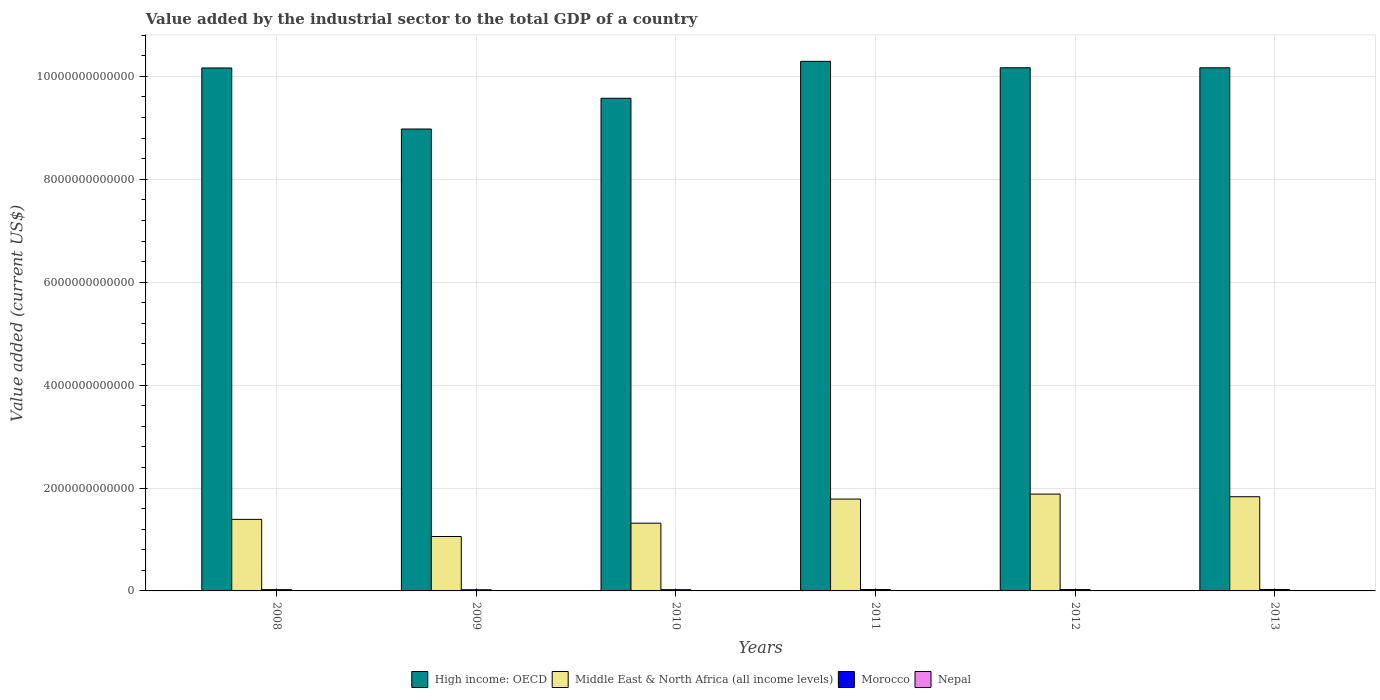How many different coloured bars are there?
Give a very brief answer. 4. How many groups of bars are there?
Make the answer very short. 6. Are the number of bars per tick equal to the number of legend labels?
Provide a succinct answer. Yes. In how many cases, is the number of bars for a given year not equal to the number of legend labels?
Ensure brevity in your answer.  0. What is the value added by the industrial sector to the total GDP in High income: OECD in 2008?
Your response must be concise. 1.02e+13. Across all years, what is the maximum value added by the industrial sector to the total GDP in Nepal?
Your answer should be compact. 2.73e+09. Across all years, what is the minimum value added by the industrial sector to the total GDP in Nepal?
Provide a succinct answer. 1.94e+09. In which year was the value added by the industrial sector to the total GDP in Nepal maximum?
Your answer should be very brief. 2013. What is the total value added by the industrial sector to the total GDP in Morocco in the graph?
Make the answer very short. 1.52e+11. What is the difference between the value added by the industrial sector to the total GDP in Morocco in 2009 and that in 2011?
Ensure brevity in your answer.  -4.46e+09. What is the difference between the value added by the industrial sector to the total GDP in Middle East & North Africa (all income levels) in 2010 and the value added by the industrial sector to the total GDP in Morocco in 2009?
Ensure brevity in your answer.  1.29e+12. What is the average value added by the industrial sector to the total GDP in Middle East & North Africa (all income levels) per year?
Provide a succinct answer. 1.54e+12. In the year 2012, what is the difference between the value added by the industrial sector to the total GDP in Morocco and value added by the industrial sector to the total GDP in Middle East & North Africa (all income levels)?
Ensure brevity in your answer.  -1.86e+12. In how many years, is the value added by the industrial sector to the total GDP in Middle East & North Africa (all income levels) greater than 4000000000000 US$?
Your response must be concise. 0. What is the ratio of the value added by the industrial sector to the total GDP in Nepal in 2010 to that in 2012?
Give a very brief answer. 0.85. What is the difference between the highest and the second highest value added by the industrial sector to the total GDP in Middle East & North Africa (all income levels)?
Offer a very short reply. 5.11e+1. What is the difference between the highest and the lowest value added by the industrial sector to the total GDP in Morocco?
Keep it short and to the point. 5.56e+09. In how many years, is the value added by the industrial sector to the total GDP in Middle East & North Africa (all income levels) greater than the average value added by the industrial sector to the total GDP in Middle East & North Africa (all income levels) taken over all years?
Offer a terse response. 3. Is the sum of the value added by the industrial sector to the total GDP in High income: OECD in 2008 and 2011 greater than the maximum value added by the industrial sector to the total GDP in Nepal across all years?
Offer a terse response. Yes. Is it the case that in every year, the sum of the value added by the industrial sector to the total GDP in High income: OECD and value added by the industrial sector to the total GDP in Morocco is greater than the sum of value added by the industrial sector to the total GDP in Middle East & North Africa (all income levels) and value added by the industrial sector to the total GDP in Nepal?
Offer a very short reply. Yes. What does the 3rd bar from the left in 2011 represents?
Offer a very short reply. Morocco. What does the 2nd bar from the right in 2011 represents?
Provide a short and direct response. Morocco. Are all the bars in the graph horizontal?
Ensure brevity in your answer.  No. How many years are there in the graph?
Your answer should be compact. 6. What is the difference between two consecutive major ticks on the Y-axis?
Provide a succinct answer. 2.00e+12. Are the values on the major ticks of Y-axis written in scientific E-notation?
Provide a short and direct response. No. Does the graph contain any zero values?
Your response must be concise. No. Where does the legend appear in the graph?
Give a very brief answer. Bottom center. How are the legend labels stacked?
Your response must be concise. Horizontal. What is the title of the graph?
Your response must be concise. Value added by the industrial sector to the total GDP of a country. What is the label or title of the Y-axis?
Ensure brevity in your answer.  Value added (current US$). What is the Value added (current US$) of High income: OECD in 2008?
Your answer should be very brief. 1.02e+13. What is the Value added (current US$) in Middle East & North Africa (all income levels) in 2008?
Provide a short and direct response. 1.39e+12. What is the Value added (current US$) in Morocco in 2008?
Provide a short and direct response. 2.48e+1. What is the Value added (current US$) of Nepal in 2008?
Provide a succinct answer. 2.01e+09. What is the Value added (current US$) of High income: OECD in 2009?
Offer a very short reply. 8.98e+12. What is the Value added (current US$) in Middle East & North Africa (all income levels) in 2009?
Make the answer very short. 1.06e+12. What is the Value added (current US$) of Morocco in 2009?
Offer a terse response. 2.25e+1. What is the Value added (current US$) in Nepal in 2009?
Make the answer very short. 1.94e+09. What is the Value added (current US$) of High income: OECD in 2010?
Keep it short and to the point. 9.57e+12. What is the Value added (current US$) of Middle East & North Africa (all income levels) in 2010?
Offer a terse response. 1.32e+12. What is the Value added (current US$) in Morocco in 2010?
Offer a very short reply. 2.39e+1. What is the Value added (current US$) of Nepal in 2010?
Keep it short and to the point. 2.27e+09. What is the Value added (current US$) in High income: OECD in 2011?
Provide a short and direct response. 1.03e+13. What is the Value added (current US$) of Middle East & North Africa (all income levels) in 2011?
Your answer should be compact. 1.79e+12. What is the Value added (current US$) in Morocco in 2011?
Provide a succinct answer. 2.70e+1. What is the Value added (current US$) of Nepal in 2011?
Give a very brief answer. 2.67e+09. What is the Value added (current US$) of High income: OECD in 2012?
Your answer should be compact. 1.02e+13. What is the Value added (current US$) of Middle East & North Africa (all income levels) in 2012?
Make the answer very short. 1.88e+12. What is the Value added (current US$) in Morocco in 2012?
Provide a succinct answer. 2.59e+1. What is the Value added (current US$) of Nepal in 2012?
Your response must be concise. 2.66e+09. What is the Value added (current US$) in High income: OECD in 2013?
Ensure brevity in your answer.  1.02e+13. What is the Value added (current US$) in Middle East & North Africa (all income levels) in 2013?
Offer a very short reply. 1.83e+12. What is the Value added (current US$) of Morocco in 2013?
Provide a succinct answer. 2.81e+1. What is the Value added (current US$) of Nepal in 2013?
Make the answer very short. 2.73e+09. Across all years, what is the maximum Value added (current US$) in High income: OECD?
Your answer should be very brief. 1.03e+13. Across all years, what is the maximum Value added (current US$) in Middle East & North Africa (all income levels)?
Your response must be concise. 1.88e+12. Across all years, what is the maximum Value added (current US$) in Morocco?
Provide a succinct answer. 2.81e+1. Across all years, what is the maximum Value added (current US$) in Nepal?
Your answer should be compact. 2.73e+09. Across all years, what is the minimum Value added (current US$) in High income: OECD?
Provide a succinct answer. 8.98e+12. Across all years, what is the minimum Value added (current US$) of Middle East & North Africa (all income levels)?
Your answer should be compact. 1.06e+12. Across all years, what is the minimum Value added (current US$) of Morocco?
Offer a terse response. 2.25e+1. Across all years, what is the minimum Value added (current US$) of Nepal?
Keep it short and to the point. 1.94e+09. What is the total Value added (current US$) in High income: OECD in the graph?
Give a very brief answer. 5.93e+13. What is the total Value added (current US$) of Middle East & North Africa (all income levels) in the graph?
Offer a terse response. 9.26e+12. What is the total Value added (current US$) of Morocco in the graph?
Give a very brief answer. 1.52e+11. What is the total Value added (current US$) of Nepal in the graph?
Your response must be concise. 1.43e+1. What is the difference between the Value added (current US$) of High income: OECD in 2008 and that in 2009?
Provide a succinct answer. 1.19e+12. What is the difference between the Value added (current US$) in Middle East & North Africa (all income levels) in 2008 and that in 2009?
Give a very brief answer. 3.33e+11. What is the difference between the Value added (current US$) in Morocco in 2008 and that in 2009?
Ensure brevity in your answer.  2.24e+09. What is the difference between the Value added (current US$) in Nepal in 2008 and that in 2009?
Keep it short and to the point. 7.67e+07. What is the difference between the Value added (current US$) of High income: OECD in 2008 and that in 2010?
Give a very brief answer. 5.89e+11. What is the difference between the Value added (current US$) of Middle East & North Africa (all income levels) in 2008 and that in 2010?
Ensure brevity in your answer.  7.39e+1. What is the difference between the Value added (current US$) in Morocco in 2008 and that in 2010?
Give a very brief answer. 8.42e+08. What is the difference between the Value added (current US$) of Nepal in 2008 and that in 2010?
Provide a succinct answer. -2.59e+08. What is the difference between the Value added (current US$) in High income: OECD in 2008 and that in 2011?
Ensure brevity in your answer.  -1.28e+11. What is the difference between the Value added (current US$) of Middle East & North Africa (all income levels) in 2008 and that in 2011?
Provide a succinct answer. -3.95e+11. What is the difference between the Value added (current US$) in Morocco in 2008 and that in 2011?
Offer a terse response. -2.22e+09. What is the difference between the Value added (current US$) of Nepal in 2008 and that in 2011?
Ensure brevity in your answer.  -6.55e+08. What is the difference between the Value added (current US$) in High income: OECD in 2008 and that in 2012?
Your response must be concise. -4.01e+09. What is the difference between the Value added (current US$) of Middle East & North Africa (all income levels) in 2008 and that in 2012?
Give a very brief answer. -4.91e+11. What is the difference between the Value added (current US$) of Morocco in 2008 and that in 2012?
Your answer should be very brief. -1.19e+09. What is the difference between the Value added (current US$) of Nepal in 2008 and that in 2012?
Offer a terse response. -6.45e+08. What is the difference between the Value added (current US$) in High income: OECD in 2008 and that in 2013?
Ensure brevity in your answer.  -3.16e+09. What is the difference between the Value added (current US$) in Middle East & North Africa (all income levels) in 2008 and that in 2013?
Offer a terse response. -4.40e+11. What is the difference between the Value added (current US$) of Morocco in 2008 and that in 2013?
Ensure brevity in your answer.  -3.32e+09. What is the difference between the Value added (current US$) in Nepal in 2008 and that in 2013?
Your response must be concise. -7.14e+08. What is the difference between the Value added (current US$) in High income: OECD in 2009 and that in 2010?
Make the answer very short. -5.98e+11. What is the difference between the Value added (current US$) of Middle East & North Africa (all income levels) in 2009 and that in 2010?
Offer a very short reply. -2.59e+11. What is the difference between the Value added (current US$) of Morocco in 2009 and that in 2010?
Ensure brevity in your answer.  -1.40e+09. What is the difference between the Value added (current US$) in Nepal in 2009 and that in 2010?
Ensure brevity in your answer.  -3.36e+08. What is the difference between the Value added (current US$) in High income: OECD in 2009 and that in 2011?
Give a very brief answer. -1.32e+12. What is the difference between the Value added (current US$) of Middle East & North Africa (all income levels) in 2009 and that in 2011?
Keep it short and to the point. -7.28e+11. What is the difference between the Value added (current US$) in Morocco in 2009 and that in 2011?
Provide a succinct answer. -4.46e+09. What is the difference between the Value added (current US$) of Nepal in 2009 and that in 2011?
Your response must be concise. -7.31e+08. What is the difference between the Value added (current US$) in High income: OECD in 2009 and that in 2012?
Offer a very short reply. -1.19e+12. What is the difference between the Value added (current US$) in Middle East & North Africa (all income levels) in 2009 and that in 2012?
Offer a terse response. -8.24e+11. What is the difference between the Value added (current US$) of Morocco in 2009 and that in 2012?
Offer a terse response. -3.43e+09. What is the difference between the Value added (current US$) of Nepal in 2009 and that in 2012?
Offer a very short reply. -7.22e+08. What is the difference between the Value added (current US$) of High income: OECD in 2009 and that in 2013?
Give a very brief answer. -1.19e+12. What is the difference between the Value added (current US$) in Middle East & North Africa (all income levels) in 2009 and that in 2013?
Your answer should be compact. -7.73e+11. What is the difference between the Value added (current US$) of Morocco in 2009 and that in 2013?
Offer a terse response. -5.56e+09. What is the difference between the Value added (current US$) of Nepal in 2009 and that in 2013?
Offer a very short reply. -7.91e+08. What is the difference between the Value added (current US$) of High income: OECD in 2010 and that in 2011?
Provide a succinct answer. -7.17e+11. What is the difference between the Value added (current US$) of Middle East & North Africa (all income levels) in 2010 and that in 2011?
Provide a short and direct response. -4.69e+11. What is the difference between the Value added (current US$) of Morocco in 2010 and that in 2011?
Your answer should be very brief. -3.06e+09. What is the difference between the Value added (current US$) of Nepal in 2010 and that in 2011?
Your answer should be compact. -3.96e+08. What is the difference between the Value added (current US$) of High income: OECD in 2010 and that in 2012?
Provide a succinct answer. -5.93e+11. What is the difference between the Value added (current US$) in Middle East & North Africa (all income levels) in 2010 and that in 2012?
Give a very brief answer. -5.65e+11. What is the difference between the Value added (current US$) in Morocco in 2010 and that in 2012?
Your answer should be compact. -2.03e+09. What is the difference between the Value added (current US$) in Nepal in 2010 and that in 2012?
Give a very brief answer. -3.86e+08. What is the difference between the Value added (current US$) in High income: OECD in 2010 and that in 2013?
Your response must be concise. -5.92e+11. What is the difference between the Value added (current US$) in Middle East & North Africa (all income levels) in 2010 and that in 2013?
Provide a succinct answer. -5.14e+11. What is the difference between the Value added (current US$) of Morocco in 2010 and that in 2013?
Your response must be concise. -4.16e+09. What is the difference between the Value added (current US$) of Nepal in 2010 and that in 2013?
Provide a short and direct response. -4.55e+08. What is the difference between the Value added (current US$) of High income: OECD in 2011 and that in 2012?
Provide a succinct answer. 1.24e+11. What is the difference between the Value added (current US$) in Middle East & North Africa (all income levels) in 2011 and that in 2012?
Provide a short and direct response. -9.65e+1. What is the difference between the Value added (current US$) of Morocco in 2011 and that in 2012?
Provide a succinct answer. 1.03e+09. What is the difference between the Value added (current US$) of Nepal in 2011 and that in 2012?
Provide a succinct answer. 9.81e+06. What is the difference between the Value added (current US$) in High income: OECD in 2011 and that in 2013?
Your answer should be very brief. 1.25e+11. What is the difference between the Value added (current US$) of Middle East & North Africa (all income levels) in 2011 and that in 2013?
Make the answer very short. -4.54e+1. What is the difference between the Value added (current US$) of Morocco in 2011 and that in 2013?
Make the answer very short. -1.10e+09. What is the difference between the Value added (current US$) in Nepal in 2011 and that in 2013?
Make the answer very short. -5.95e+07. What is the difference between the Value added (current US$) of High income: OECD in 2012 and that in 2013?
Ensure brevity in your answer.  8.50e+08. What is the difference between the Value added (current US$) in Middle East & North Africa (all income levels) in 2012 and that in 2013?
Provide a short and direct response. 5.11e+1. What is the difference between the Value added (current US$) of Morocco in 2012 and that in 2013?
Offer a very short reply. -2.13e+09. What is the difference between the Value added (current US$) in Nepal in 2012 and that in 2013?
Your answer should be very brief. -6.93e+07. What is the difference between the Value added (current US$) in High income: OECD in 2008 and the Value added (current US$) in Middle East & North Africa (all income levels) in 2009?
Make the answer very short. 9.11e+12. What is the difference between the Value added (current US$) of High income: OECD in 2008 and the Value added (current US$) of Morocco in 2009?
Offer a very short reply. 1.01e+13. What is the difference between the Value added (current US$) in High income: OECD in 2008 and the Value added (current US$) in Nepal in 2009?
Your answer should be very brief. 1.02e+13. What is the difference between the Value added (current US$) in Middle East & North Africa (all income levels) in 2008 and the Value added (current US$) in Morocco in 2009?
Ensure brevity in your answer.  1.37e+12. What is the difference between the Value added (current US$) in Middle East & North Africa (all income levels) in 2008 and the Value added (current US$) in Nepal in 2009?
Ensure brevity in your answer.  1.39e+12. What is the difference between the Value added (current US$) in Morocco in 2008 and the Value added (current US$) in Nepal in 2009?
Your answer should be very brief. 2.28e+1. What is the difference between the Value added (current US$) in High income: OECD in 2008 and the Value added (current US$) in Middle East & North Africa (all income levels) in 2010?
Your response must be concise. 8.85e+12. What is the difference between the Value added (current US$) of High income: OECD in 2008 and the Value added (current US$) of Morocco in 2010?
Provide a short and direct response. 1.01e+13. What is the difference between the Value added (current US$) in High income: OECD in 2008 and the Value added (current US$) in Nepal in 2010?
Give a very brief answer. 1.02e+13. What is the difference between the Value added (current US$) of Middle East & North Africa (all income levels) in 2008 and the Value added (current US$) of Morocco in 2010?
Keep it short and to the point. 1.37e+12. What is the difference between the Value added (current US$) in Middle East & North Africa (all income levels) in 2008 and the Value added (current US$) in Nepal in 2010?
Provide a succinct answer. 1.39e+12. What is the difference between the Value added (current US$) in Morocco in 2008 and the Value added (current US$) in Nepal in 2010?
Give a very brief answer. 2.25e+1. What is the difference between the Value added (current US$) of High income: OECD in 2008 and the Value added (current US$) of Middle East & North Africa (all income levels) in 2011?
Give a very brief answer. 8.38e+12. What is the difference between the Value added (current US$) in High income: OECD in 2008 and the Value added (current US$) in Morocco in 2011?
Make the answer very short. 1.01e+13. What is the difference between the Value added (current US$) in High income: OECD in 2008 and the Value added (current US$) in Nepal in 2011?
Give a very brief answer. 1.02e+13. What is the difference between the Value added (current US$) in Middle East & North Africa (all income levels) in 2008 and the Value added (current US$) in Morocco in 2011?
Provide a succinct answer. 1.36e+12. What is the difference between the Value added (current US$) in Middle East & North Africa (all income levels) in 2008 and the Value added (current US$) in Nepal in 2011?
Your response must be concise. 1.39e+12. What is the difference between the Value added (current US$) in Morocco in 2008 and the Value added (current US$) in Nepal in 2011?
Offer a very short reply. 2.21e+1. What is the difference between the Value added (current US$) in High income: OECD in 2008 and the Value added (current US$) in Middle East & North Africa (all income levels) in 2012?
Make the answer very short. 8.28e+12. What is the difference between the Value added (current US$) of High income: OECD in 2008 and the Value added (current US$) of Morocco in 2012?
Keep it short and to the point. 1.01e+13. What is the difference between the Value added (current US$) in High income: OECD in 2008 and the Value added (current US$) in Nepal in 2012?
Ensure brevity in your answer.  1.02e+13. What is the difference between the Value added (current US$) of Middle East & North Africa (all income levels) in 2008 and the Value added (current US$) of Morocco in 2012?
Give a very brief answer. 1.36e+12. What is the difference between the Value added (current US$) of Middle East & North Africa (all income levels) in 2008 and the Value added (current US$) of Nepal in 2012?
Your answer should be compact. 1.39e+12. What is the difference between the Value added (current US$) of Morocco in 2008 and the Value added (current US$) of Nepal in 2012?
Keep it short and to the point. 2.21e+1. What is the difference between the Value added (current US$) in High income: OECD in 2008 and the Value added (current US$) in Middle East & North Africa (all income levels) in 2013?
Keep it short and to the point. 8.33e+12. What is the difference between the Value added (current US$) of High income: OECD in 2008 and the Value added (current US$) of Morocco in 2013?
Ensure brevity in your answer.  1.01e+13. What is the difference between the Value added (current US$) in High income: OECD in 2008 and the Value added (current US$) in Nepal in 2013?
Your answer should be very brief. 1.02e+13. What is the difference between the Value added (current US$) of Middle East & North Africa (all income levels) in 2008 and the Value added (current US$) of Morocco in 2013?
Keep it short and to the point. 1.36e+12. What is the difference between the Value added (current US$) of Middle East & North Africa (all income levels) in 2008 and the Value added (current US$) of Nepal in 2013?
Keep it short and to the point. 1.39e+12. What is the difference between the Value added (current US$) in Morocco in 2008 and the Value added (current US$) in Nepal in 2013?
Keep it short and to the point. 2.20e+1. What is the difference between the Value added (current US$) of High income: OECD in 2009 and the Value added (current US$) of Middle East & North Africa (all income levels) in 2010?
Keep it short and to the point. 7.66e+12. What is the difference between the Value added (current US$) in High income: OECD in 2009 and the Value added (current US$) in Morocco in 2010?
Your answer should be compact. 8.95e+12. What is the difference between the Value added (current US$) of High income: OECD in 2009 and the Value added (current US$) of Nepal in 2010?
Your answer should be very brief. 8.97e+12. What is the difference between the Value added (current US$) of Middle East & North Africa (all income levels) in 2009 and the Value added (current US$) of Morocco in 2010?
Provide a short and direct response. 1.03e+12. What is the difference between the Value added (current US$) of Middle East & North Africa (all income levels) in 2009 and the Value added (current US$) of Nepal in 2010?
Your answer should be compact. 1.06e+12. What is the difference between the Value added (current US$) of Morocco in 2009 and the Value added (current US$) of Nepal in 2010?
Make the answer very short. 2.02e+1. What is the difference between the Value added (current US$) of High income: OECD in 2009 and the Value added (current US$) of Middle East & North Africa (all income levels) in 2011?
Provide a short and direct response. 7.19e+12. What is the difference between the Value added (current US$) in High income: OECD in 2009 and the Value added (current US$) in Morocco in 2011?
Your answer should be compact. 8.95e+12. What is the difference between the Value added (current US$) of High income: OECD in 2009 and the Value added (current US$) of Nepal in 2011?
Make the answer very short. 8.97e+12. What is the difference between the Value added (current US$) of Middle East & North Africa (all income levels) in 2009 and the Value added (current US$) of Morocco in 2011?
Give a very brief answer. 1.03e+12. What is the difference between the Value added (current US$) of Middle East & North Africa (all income levels) in 2009 and the Value added (current US$) of Nepal in 2011?
Provide a succinct answer. 1.05e+12. What is the difference between the Value added (current US$) in Morocco in 2009 and the Value added (current US$) in Nepal in 2011?
Ensure brevity in your answer.  1.98e+1. What is the difference between the Value added (current US$) in High income: OECD in 2009 and the Value added (current US$) in Middle East & North Africa (all income levels) in 2012?
Provide a short and direct response. 7.10e+12. What is the difference between the Value added (current US$) in High income: OECD in 2009 and the Value added (current US$) in Morocco in 2012?
Provide a succinct answer. 8.95e+12. What is the difference between the Value added (current US$) in High income: OECD in 2009 and the Value added (current US$) in Nepal in 2012?
Provide a succinct answer. 8.97e+12. What is the difference between the Value added (current US$) of Middle East & North Africa (all income levels) in 2009 and the Value added (current US$) of Morocco in 2012?
Offer a very short reply. 1.03e+12. What is the difference between the Value added (current US$) in Middle East & North Africa (all income levels) in 2009 and the Value added (current US$) in Nepal in 2012?
Offer a terse response. 1.05e+12. What is the difference between the Value added (current US$) of Morocco in 2009 and the Value added (current US$) of Nepal in 2012?
Your response must be concise. 1.99e+1. What is the difference between the Value added (current US$) in High income: OECD in 2009 and the Value added (current US$) in Middle East & North Africa (all income levels) in 2013?
Ensure brevity in your answer.  7.15e+12. What is the difference between the Value added (current US$) in High income: OECD in 2009 and the Value added (current US$) in Morocco in 2013?
Offer a terse response. 8.95e+12. What is the difference between the Value added (current US$) of High income: OECD in 2009 and the Value added (current US$) of Nepal in 2013?
Keep it short and to the point. 8.97e+12. What is the difference between the Value added (current US$) of Middle East & North Africa (all income levels) in 2009 and the Value added (current US$) of Morocco in 2013?
Your answer should be compact. 1.03e+12. What is the difference between the Value added (current US$) in Middle East & North Africa (all income levels) in 2009 and the Value added (current US$) in Nepal in 2013?
Your answer should be very brief. 1.05e+12. What is the difference between the Value added (current US$) of Morocco in 2009 and the Value added (current US$) of Nepal in 2013?
Your answer should be compact. 1.98e+1. What is the difference between the Value added (current US$) in High income: OECD in 2010 and the Value added (current US$) in Middle East & North Africa (all income levels) in 2011?
Ensure brevity in your answer.  7.79e+12. What is the difference between the Value added (current US$) in High income: OECD in 2010 and the Value added (current US$) in Morocco in 2011?
Your response must be concise. 9.55e+12. What is the difference between the Value added (current US$) of High income: OECD in 2010 and the Value added (current US$) of Nepal in 2011?
Keep it short and to the point. 9.57e+12. What is the difference between the Value added (current US$) in Middle East & North Africa (all income levels) in 2010 and the Value added (current US$) in Morocco in 2011?
Give a very brief answer. 1.29e+12. What is the difference between the Value added (current US$) of Middle East & North Africa (all income levels) in 2010 and the Value added (current US$) of Nepal in 2011?
Make the answer very short. 1.31e+12. What is the difference between the Value added (current US$) in Morocco in 2010 and the Value added (current US$) in Nepal in 2011?
Offer a very short reply. 2.12e+1. What is the difference between the Value added (current US$) in High income: OECD in 2010 and the Value added (current US$) in Middle East & North Africa (all income levels) in 2012?
Offer a very short reply. 7.69e+12. What is the difference between the Value added (current US$) in High income: OECD in 2010 and the Value added (current US$) in Morocco in 2012?
Your response must be concise. 9.55e+12. What is the difference between the Value added (current US$) of High income: OECD in 2010 and the Value added (current US$) of Nepal in 2012?
Your answer should be compact. 9.57e+12. What is the difference between the Value added (current US$) in Middle East & North Africa (all income levels) in 2010 and the Value added (current US$) in Morocco in 2012?
Make the answer very short. 1.29e+12. What is the difference between the Value added (current US$) of Middle East & North Africa (all income levels) in 2010 and the Value added (current US$) of Nepal in 2012?
Keep it short and to the point. 1.31e+12. What is the difference between the Value added (current US$) of Morocco in 2010 and the Value added (current US$) of Nepal in 2012?
Offer a very short reply. 2.13e+1. What is the difference between the Value added (current US$) in High income: OECD in 2010 and the Value added (current US$) in Middle East & North Africa (all income levels) in 2013?
Offer a very short reply. 7.74e+12. What is the difference between the Value added (current US$) in High income: OECD in 2010 and the Value added (current US$) in Morocco in 2013?
Offer a terse response. 9.55e+12. What is the difference between the Value added (current US$) of High income: OECD in 2010 and the Value added (current US$) of Nepal in 2013?
Provide a short and direct response. 9.57e+12. What is the difference between the Value added (current US$) of Middle East & North Africa (all income levels) in 2010 and the Value added (current US$) of Morocco in 2013?
Offer a terse response. 1.29e+12. What is the difference between the Value added (current US$) in Middle East & North Africa (all income levels) in 2010 and the Value added (current US$) in Nepal in 2013?
Your response must be concise. 1.31e+12. What is the difference between the Value added (current US$) in Morocco in 2010 and the Value added (current US$) in Nepal in 2013?
Make the answer very short. 2.12e+1. What is the difference between the Value added (current US$) of High income: OECD in 2011 and the Value added (current US$) of Middle East & North Africa (all income levels) in 2012?
Ensure brevity in your answer.  8.41e+12. What is the difference between the Value added (current US$) of High income: OECD in 2011 and the Value added (current US$) of Morocco in 2012?
Your answer should be very brief. 1.03e+13. What is the difference between the Value added (current US$) in High income: OECD in 2011 and the Value added (current US$) in Nepal in 2012?
Give a very brief answer. 1.03e+13. What is the difference between the Value added (current US$) of Middle East & North Africa (all income levels) in 2011 and the Value added (current US$) of Morocco in 2012?
Your answer should be very brief. 1.76e+12. What is the difference between the Value added (current US$) of Middle East & North Africa (all income levels) in 2011 and the Value added (current US$) of Nepal in 2012?
Provide a succinct answer. 1.78e+12. What is the difference between the Value added (current US$) in Morocco in 2011 and the Value added (current US$) in Nepal in 2012?
Your answer should be very brief. 2.43e+1. What is the difference between the Value added (current US$) of High income: OECD in 2011 and the Value added (current US$) of Middle East & North Africa (all income levels) in 2013?
Offer a terse response. 8.46e+12. What is the difference between the Value added (current US$) of High income: OECD in 2011 and the Value added (current US$) of Morocco in 2013?
Offer a very short reply. 1.03e+13. What is the difference between the Value added (current US$) in High income: OECD in 2011 and the Value added (current US$) in Nepal in 2013?
Provide a succinct answer. 1.03e+13. What is the difference between the Value added (current US$) of Middle East & North Africa (all income levels) in 2011 and the Value added (current US$) of Morocco in 2013?
Your answer should be very brief. 1.76e+12. What is the difference between the Value added (current US$) in Middle East & North Africa (all income levels) in 2011 and the Value added (current US$) in Nepal in 2013?
Your answer should be compact. 1.78e+12. What is the difference between the Value added (current US$) in Morocco in 2011 and the Value added (current US$) in Nepal in 2013?
Provide a short and direct response. 2.42e+1. What is the difference between the Value added (current US$) of High income: OECD in 2012 and the Value added (current US$) of Middle East & North Africa (all income levels) in 2013?
Make the answer very short. 8.34e+12. What is the difference between the Value added (current US$) in High income: OECD in 2012 and the Value added (current US$) in Morocco in 2013?
Offer a terse response. 1.01e+13. What is the difference between the Value added (current US$) in High income: OECD in 2012 and the Value added (current US$) in Nepal in 2013?
Offer a very short reply. 1.02e+13. What is the difference between the Value added (current US$) in Middle East & North Africa (all income levels) in 2012 and the Value added (current US$) in Morocco in 2013?
Provide a succinct answer. 1.85e+12. What is the difference between the Value added (current US$) in Middle East & North Africa (all income levels) in 2012 and the Value added (current US$) in Nepal in 2013?
Provide a short and direct response. 1.88e+12. What is the difference between the Value added (current US$) of Morocco in 2012 and the Value added (current US$) of Nepal in 2013?
Your answer should be very brief. 2.32e+1. What is the average Value added (current US$) in High income: OECD per year?
Keep it short and to the point. 9.89e+12. What is the average Value added (current US$) of Middle East & North Africa (all income levels) per year?
Provide a short and direct response. 1.54e+12. What is the average Value added (current US$) of Morocco per year?
Offer a terse response. 2.54e+1. What is the average Value added (current US$) of Nepal per year?
Your answer should be very brief. 2.38e+09. In the year 2008, what is the difference between the Value added (current US$) of High income: OECD and Value added (current US$) of Middle East & North Africa (all income levels)?
Offer a terse response. 8.77e+12. In the year 2008, what is the difference between the Value added (current US$) in High income: OECD and Value added (current US$) in Morocco?
Make the answer very short. 1.01e+13. In the year 2008, what is the difference between the Value added (current US$) of High income: OECD and Value added (current US$) of Nepal?
Your answer should be very brief. 1.02e+13. In the year 2008, what is the difference between the Value added (current US$) of Middle East & North Africa (all income levels) and Value added (current US$) of Morocco?
Your answer should be compact. 1.37e+12. In the year 2008, what is the difference between the Value added (current US$) in Middle East & North Africa (all income levels) and Value added (current US$) in Nepal?
Your answer should be compact. 1.39e+12. In the year 2008, what is the difference between the Value added (current US$) in Morocco and Value added (current US$) in Nepal?
Give a very brief answer. 2.27e+1. In the year 2009, what is the difference between the Value added (current US$) in High income: OECD and Value added (current US$) in Middle East & North Africa (all income levels)?
Make the answer very short. 7.92e+12. In the year 2009, what is the difference between the Value added (current US$) in High income: OECD and Value added (current US$) in Morocco?
Provide a short and direct response. 8.95e+12. In the year 2009, what is the difference between the Value added (current US$) in High income: OECD and Value added (current US$) in Nepal?
Ensure brevity in your answer.  8.98e+12. In the year 2009, what is the difference between the Value added (current US$) in Middle East & North Africa (all income levels) and Value added (current US$) in Morocco?
Offer a very short reply. 1.04e+12. In the year 2009, what is the difference between the Value added (current US$) of Middle East & North Africa (all income levels) and Value added (current US$) of Nepal?
Your response must be concise. 1.06e+12. In the year 2009, what is the difference between the Value added (current US$) in Morocco and Value added (current US$) in Nepal?
Offer a very short reply. 2.06e+1. In the year 2010, what is the difference between the Value added (current US$) in High income: OECD and Value added (current US$) in Middle East & North Africa (all income levels)?
Offer a terse response. 8.26e+12. In the year 2010, what is the difference between the Value added (current US$) in High income: OECD and Value added (current US$) in Morocco?
Offer a very short reply. 9.55e+12. In the year 2010, what is the difference between the Value added (current US$) in High income: OECD and Value added (current US$) in Nepal?
Your answer should be compact. 9.57e+12. In the year 2010, what is the difference between the Value added (current US$) of Middle East & North Africa (all income levels) and Value added (current US$) of Morocco?
Provide a short and direct response. 1.29e+12. In the year 2010, what is the difference between the Value added (current US$) of Middle East & North Africa (all income levels) and Value added (current US$) of Nepal?
Your answer should be very brief. 1.31e+12. In the year 2010, what is the difference between the Value added (current US$) of Morocco and Value added (current US$) of Nepal?
Your answer should be compact. 2.16e+1. In the year 2011, what is the difference between the Value added (current US$) in High income: OECD and Value added (current US$) in Middle East & North Africa (all income levels)?
Offer a very short reply. 8.51e+12. In the year 2011, what is the difference between the Value added (current US$) in High income: OECD and Value added (current US$) in Morocco?
Ensure brevity in your answer.  1.03e+13. In the year 2011, what is the difference between the Value added (current US$) of High income: OECD and Value added (current US$) of Nepal?
Your answer should be compact. 1.03e+13. In the year 2011, what is the difference between the Value added (current US$) in Middle East & North Africa (all income levels) and Value added (current US$) in Morocco?
Your answer should be very brief. 1.76e+12. In the year 2011, what is the difference between the Value added (current US$) in Middle East & North Africa (all income levels) and Value added (current US$) in Nepal?
Offer a very short reply. 1.78e+12. In the year 2011, what is the difference between the Value added (current US$) of Morocco and Value added (current US$) of Nepal?
Make the answer very short. 2.43e+1. In the year 2012, what is the difference between the Value added (current US$) in High income: OECD and Value added (current US$) in Middle East & North Africa (all income levels)?
Your response must be concise. 8.29e+12. In the year 2012, what is the difference between the Value added (current US$) in High income: OECD and Value added (current US$) in Morocco?
Offer a very short reply. 1.01e+13. In the year 2012, what is the difference between the Value added (current US$) in High income: OECD and Value added (current US$) in Nepal?
Keep it short and to the point. 1.02e+13. In the year 2012, what is the difference between the Value added (current US$) in Middle East & North Africa (all income levels) and Value added (current US$) in Morocco?
Provide a short and direct response. 1.86e+12. In the year 2012, what is the difference between the Value added (current US$) of Middle East & North Africa (all income levels) and Value added (current US$) of Nepal?
Provide a short and direct response. 1.88e+12. In the year 2012, what is the difference between the Value added (current US$) of Morocco and Value added (current US$) of Nepal?
Your response must be concise. 2.33e+1. In the year 2013, what is the difference between the Value added (current US$) in High income: OECD and Value added (current US$) in Middle East & North Africa (all income levels)?
Make the answer very short. 8.34e+12. In the year 2013, what is the difference between the Value added (current US$) in High income: OECD and Value added (current US$) in Morocco?
Offer a terse response. 1.01e+13. In the year 2013, what is the difference between the Value added (current US$) in High income: OECD and Value added (current US$) in Nepal?
Make the answer very short. 1.02e+13. In the year 2013, what is the difference between the Value added (current US$) of Middle East & North Africa (all income levels) and Value added (current US$) of Morocco?
Make the answer very short. 1.80e+12. In the year 2013, what is the difference between the Value added (current US$) of Middle East & North Africa (all income levels) and Value added (current US$) of Nepal?
Offer a terse response. 1.83e+12. In the year 2013, what is the difference between the Value added (current US$) in Morocco and Value added (current US$) in Nepal?
Your response must be concise. 2.54e+1. What is the ratio of the Value added (current US$) of High income: OECD in 2008 to that in 2009?
Offer a very short reply. 1.13. What is the ratio of the Value added (current US$) of Middle East & North Africa (all income levels) in 2008 to that in 2009?
Your answer should be compact. 1.31. What is the ratio of the Value added (current US$) in Morocco in 2008 to that in 2009?
Offer a very short reply. 1.1. What is the ratio of the Value added (current US$) of Nepal in 2008 to that in 2009?
Your response must be concise. 1.04. What is the ratio of the Value added (current US$) in High income: OECD in 2008 to that in 2010?
Offer a terse response. 1.06. What is the ratio of the Value added (current US$) in Middle East & North Africa (all income levels) in 2008 to that in 2010?
Give a very brief answer. 1.06. What is the ratio of the Value added (current US$) of Morocco in 2008 to that in 2010?
Your answer should be compact. 1.04. What is the ratio of the Value added (current US$) of Nepal in 2008 to that in 2010?
Offer a terse response. 0.89. What is the ratio of the Value added (current US$) in High income: OECD in 2008 to that in 2011?
Your answer should be very brief. 0.99. What is the ratio of the Value added (current US$) in Middle East & North Africa (all income levels) in 2008 to that in 2011?
Ensure brevity in your answer.  0.78. What is the ratio of the Value added (current US$) of Morocco in 2008 to that in 2011?
Offer a terse response. 0.92. What is the ratio of the Value added (current US$) of Nepal in 2008 to that in 2011?
Your answer should be compact. 0.75. What is the ratio of the Value added (current US$) in Middle East & North Africa (all income levels) in 2008 to that in 2012?
Provide a short and direct response. 0.74. What is the ratio of the Value added (current US$) of Morocco in 2008 to that in 2012?
Offer a terse response. 0.95. What is the ratio of the Value added (current US$) in Nepal in 2008 to that in 2012?
Your answer should be compact. 0.76. What is the ratio of the Value added (current US$) in High income: OECD in 2008 to that in 2013?
Offer a terse response. 1. What is the ratio of the Value added (current US$) in Middle East & North Africa (all income levels) in 2008 to that in 2013?
Make the answer very short. 0.76. What is the ratio of the Value added (current US$) in Morocco in 2008 to that in 2013?
Keep it short and to the point. 0.88. What is the ratio of the Value added (current US$) of Nepal in 2008 to that in 2013?
Your answer should be very brief. 0.74. What is the ratio of the Value added (current US$) in High income: OECD in 2009 to that in 2010?
Provide a succinct answer. 0.94. What is the ratio of the Value added (current US$) in Middle East & North Africa (all income levels) in 2009 to that in 2010?
Your answer should be very brief. 0.8. What is the ratio of the Value added (current US$) of Morocco in 2009 to that in 2010?
Keep it short and to the point. 0.94. What is the ratio of the Value added (current US$) of Nepal in 2009 to that in 2010?
Your answer should be compact. 0.85. What is the ratio of the Value added (current US$) of High income: OECD in 2009 to that in 2011?
Give a very brief answer. 0.87. What is the ratio of the Value added (current US$) of Middle East & North Africa (all income levels) in 2009 to that in 2011?
Offer a very short reply. 0.59. What is the ratio of the Value added (current US$) in Morocco in 2009 to that in 2011?
Provide a short and direct response. 0.83. What is the ratio of the Value added (current US$) in Nepal in 2009 to that in 2011?
Give a very brief answer. 0.73. What is the ratio of the Value added (current US$) in High income: OECD in 2009 to that in 2012?
Your response must be concise. 0.88. What is the ratio of the Value added (current US$) of Middle East & North Africa (all income levels) in 2009 to that in 2012?
Ensure brevity in your answer.  0.56. What is the ratio of the Value added (current US$) in Morocco in 2009 to that in 2012?
Provide a short and direct response. 0.87. What is the ratio of the Value added (current US$) of Nepal in 2009 to that in 2012?
Offer a very short reply. 0.73. What is the ratio of the Value added (current US$) of High income: OECD in 2009 to that in 2013?
Your response must be concise. 0.88. What is the ratio of the Value added (current US$) in Middle East & North Africa (all income levels) in 2009 to that in 2013?
Your answer should be compact. 0.58. What is the ratio of the Value added (current US$) of Morocco in 2009 to that in 2013?
Offer a terse response. 0.8. What is the ratio of the Value added (current US$) of Nepal in 2009 to that in 2013?
Offer a terse response. 0.71. What is the ratio of the Value added (current US$) of High income: OECD in 2010 to that in 2011?
Provide a short and direct response. 0.93. What is the ratio of the Value added (current US$) of Middle East & North Africa (all income levels) in 2010 to that in 2011?
Your answer should be very brief. 0.74. What is the ratio of the Value added (current US$) of Morocco in 2010 to that in 2011?
Your answer should be compact. 0.89. What is the ratio of the Value added (current US$) of Nepal in 2010 to that in 2011?
Make the answer very short. 0.85. What is the ratio of the Value added (current US$) in High income: OECD in 2010 to that in 2012?
Make the answer very short. 0.94. What is the ratio of the Value added (current US$) in Middle East & North Africa (all income levels) in 2010 to that in 2012?
Offer a very short reply. 0.7. What is the ratio of the Value added (current US$) in Morocco in 2010 to that in 2012?
Your response must be concise. 0.92. What is the ratio of the Value added (current US$) in Nepal in 2010 to that in 2012?
Give a very brief answer. 0.85. What is the ratio of the Value added (current US$) of High income: OECD in 2010 to that in 2013?
Keep it short and to the point. 0.94. What is the ratio of the Value added (current US$) of Middle East & North Africa (all income levels) in 2010 to that in 2013?
Give a very brief answer. 0.72. What is the ratio of the Value added (current US$) of Morocco in 2010 to that in 2013?
Your response must be concise. 0.85. What is the ratio of the Value added (current US$) in Nepal in 2010 to that in 2013?
Offer a very short reply. 0.83. What is the ratio of the Value added (current US$) of High income: OECD in 2011 to that in 2012?
Offer a very short reply. 1.01. What is the ratio of the Value added (current US$) in Middle East & North Africa (all income levels) in 2011 to that in 2012?
Offer a very short reply. 0.95. What is the ratio of the Value added (current US$) of Morocco in 2011 to that in 2012?
Make the answer very short. 1.04. What is the ratio of the Value added (current US$) in High income: OECD in 2011 to that in 2013?
Ensure brevity in your answer.  1.01. What is the ratio of the Value added (current US$) in Middle East & North Africa (all income levels) in 2011 to that in 2013?
Provide a succinct answer. 0.98. What is the ratio of the Value added (current US$) of Morocco in 2011 to that in 2013?
Offer a terse response. 0.96. What is the ratio of the Value added (current US$) in Nepal in 2011 to that in 2013?
Your answer should be compact. 0.98. What is the ratio of the Value added (current US$) in High income: OECD in 2012 to that in 2013?
Ensure brevity in your answer.  1. What is the ratio of the Value added (current US$) of Middle East & North Africa (all income levels) in 2012 to that in 2013?
Your response must be concise. 1.03. What is the ratio of the Value added (current US$) in Morocco in 2012 to that in 2013?
Keep it short and to the point. 0.92. What is the ratio of the Value added (current US$) in Nepal in 2012 to that in 2013?
Provide a short and direct response. 0.97. What is the difference between the highest and the second highest Value added (current US$) of High income: OECD?
Your answer should be very brief. 1.24e+11. What is the difference between the highest and the second highest Value added (current US$) of Middle East & North Africa (all income levels)?
Your answer should be very brief. 5.11e+1. What is the difference between the highest and the second highest Value added (current US$) in Morocco?
Offer a very short reply. 1.10e+09. What is the difference between the highest and the second highest Value added (current US$) in Nepal?
Offer a terse response. 5.95e+07. What is the difference between the highest and the lowest Value added (current US$) of High income: OECD?
Provide a short and direct response. 1.32e+12. What is the difference between the highest and the lowest Value added (current US$) of Middle East & North Africa (all income levels)?
Make the answer very short. 8.24e+11. What is the difference between the highest and the lowest Value added (current US$) in Morocco?
Provide a succinct answer. 5.56e+09. What is the difference between the highest and the lowest Value added (current US$) of Nepal?
Offer a terse response. 7.91e+08. 